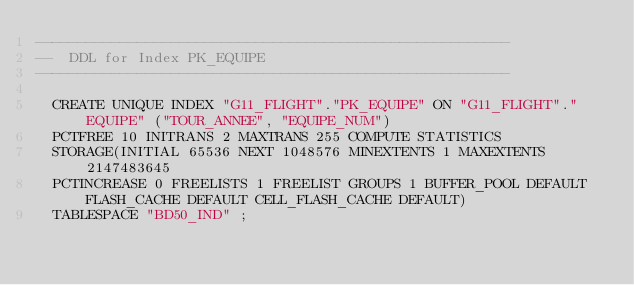Convert code to text. <code><loc_0><loc_0><loc_500><loc_500><_SQL_>--------------------------------------------------------
--  DDL for Index PK_EQUIPE
--------------------------------------------------------

  CREATE UNIQUE INDEX "G11_FLIGHT"."PK_EQUIPE" ON "G11_FLIGHT"."EQUIPE" ("TOUR_ANNEE", "EQUIPE_NUM") 
  PCTFREE 10 INITRANS 2 MAXTRANS 255 COMPUTE STATISTICS 
  STORAGE(INITIAL 65536 NEXT 1048576 MINEXTENTS 1 MAXEXTENTS 2147483645
  PCTINCREASE 0 FREELISTS 1 FREELIST GROUPS 1 BUFFER_POOL DEFAULT FLASH_CACHE DEFAULT CELL_FLASH_CACHE DEFAULT)
  TABLESPACE "BD50_IND" ;
</code> 